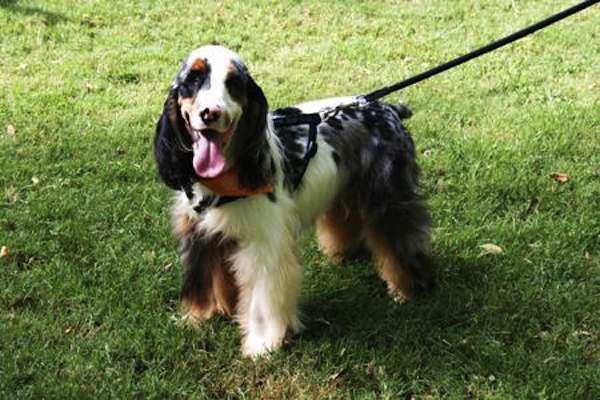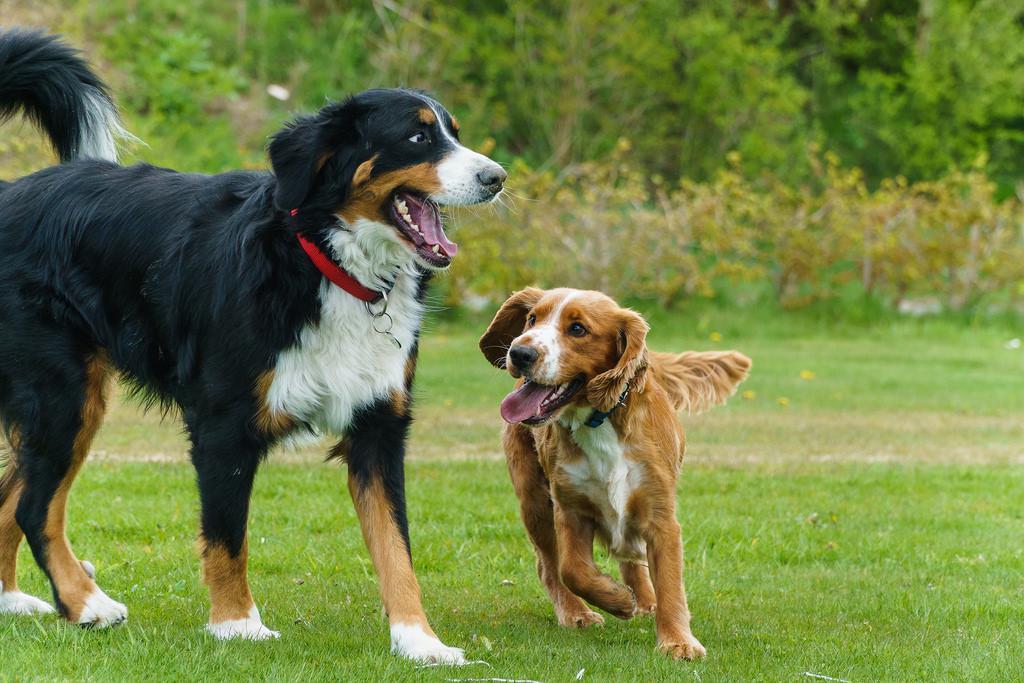The first image is the image on the left, the second image is the image on the right. For the images shown, is this caption "The left image contains a single standing dog, and the right image shows two dogs interacting outdoors." true? Answer yes or no. Yes. 